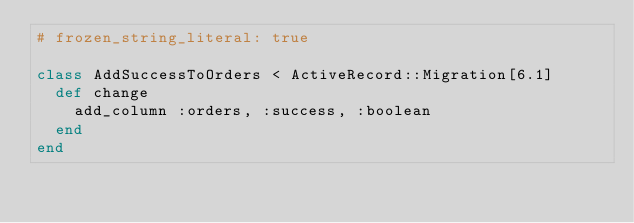<code> <loc_0><loc_0><loc_500><loc_500><_Ruby_># frozen_string_literal: true

class AddSuccessToOrders < ActiveRecord::Migration[6.1]
  def change
    add_column :orders, :success, :boolean
  end
end
</code> 